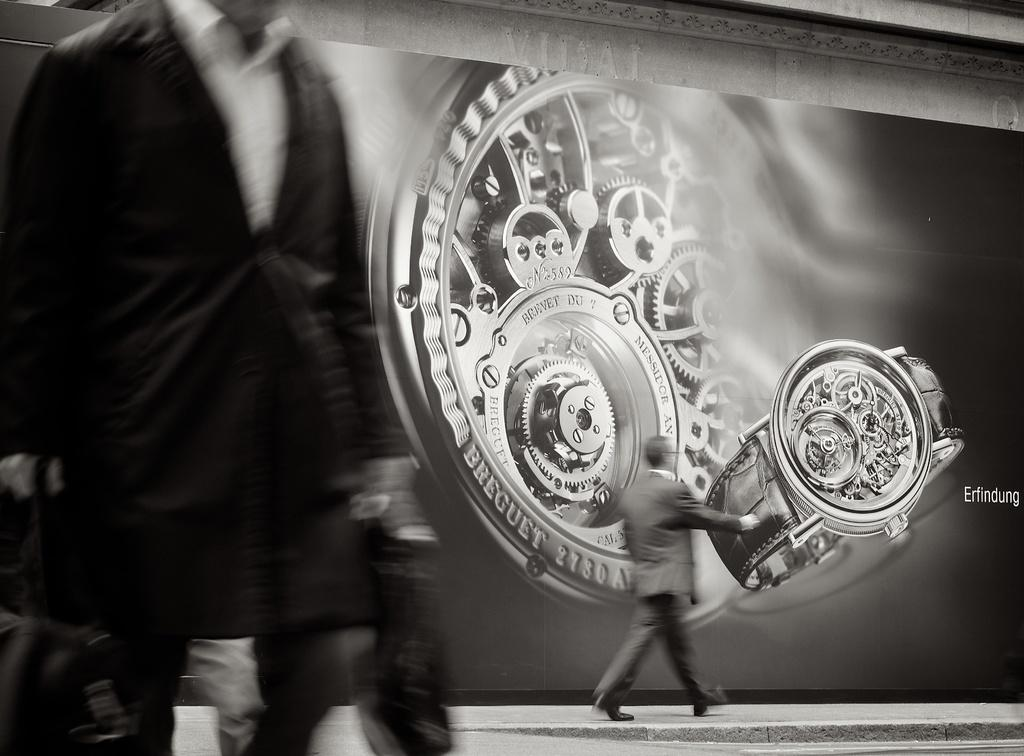<image>
Provide a brief description of the given image. men are walking by a huge Erfindung display of the inside of their watch 